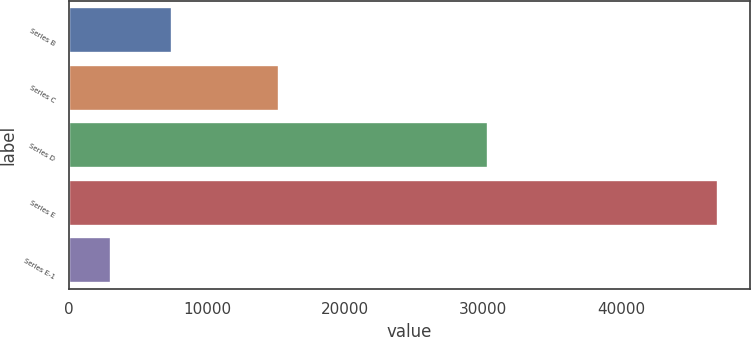Convert chart to OTSL. <chart><loc_0><loc_0><loc_500><loc_500><bar_chart><fcel>Series B<fcel>Series C<fcel>Series D<fcel>Series E<fcel>Series E-1<nl><fcel>7442.1<fcel>15205<fcel>30318<fcel>46971<fcel>3050<nl></chart> 